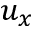Convert formula to latex. <formula><loc_0><loc_0><loc_500><loc_500>u _ { x }</formula> 